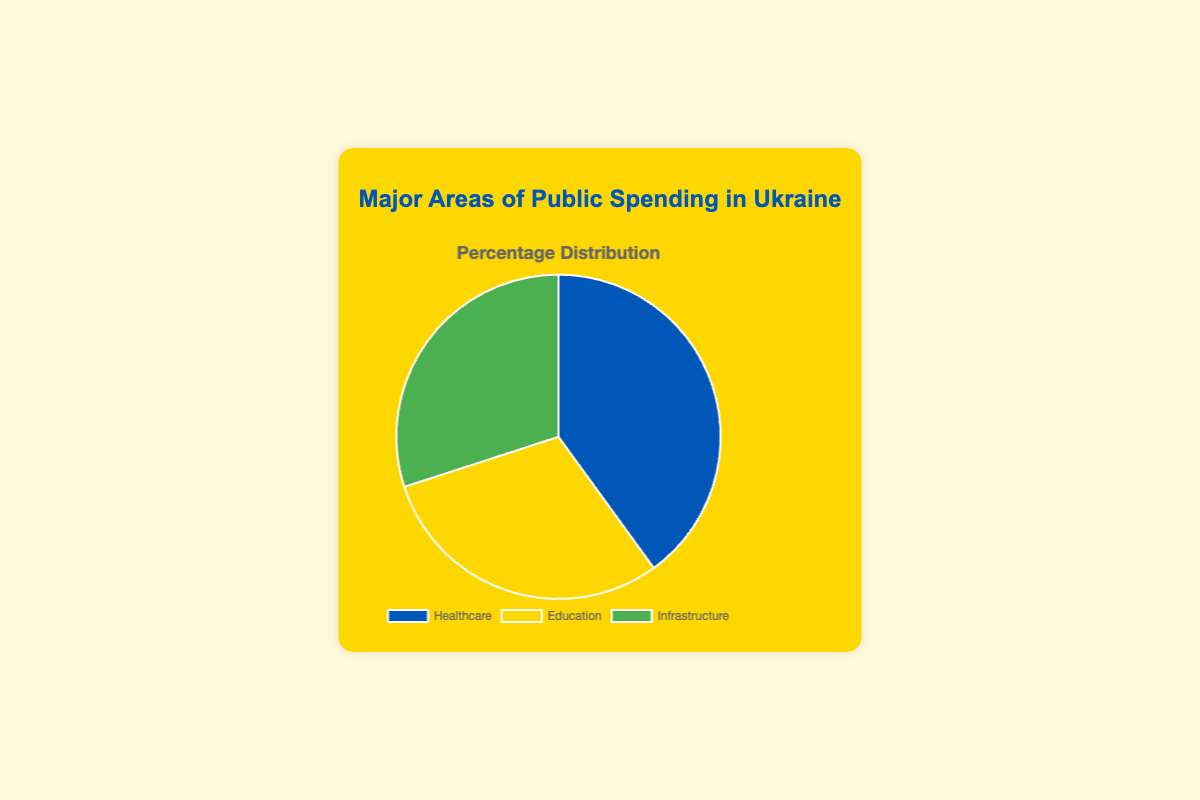Which category has the highest percentage? The pie chart shows the data distribution among Healthcare, Education, and Infrastructure. Healthcare is shown as having the largest slice of 40%.
Answer: Healthcare What is the total percentage of spending on Education and Infrastructure? The pie chart displays Education at 30% and Infrastructure at 30%. Adding these two percentages together gives 30% + 30% = 60%.
Answer: 60% Among Healthcare, Education, and Infrastructure, which two categories have equal spending? By examining the pie chart, it is evident that both Education and Infrastructure each make up 30% of the total spending.
Answer: Education and Infrastructure What is the percentage difference between Healthcare and Education? The pie chart shows Healthcare at 40% and Education at 30%. The difference is 40% - 30% = 10%.
Answer: 10% Which category is represented by the green section of the pie chart? The chart uses different colors for each category. The green section corresponds to Infrastructure as indicated in the legend.
Answer: Infrastructure Calculate the average percentage spent on all three categories. The data points provided are 40% for Healthcare, 30% for Education, and 30% for Infrastructure. The average is calculated as (40% + 30% + 30%) / 3 = 100% / 3 = 33.33%.
Answer: 33.33% What is the ratio of spending on Healthcare to Education? The chart indicates Healthcare at 40% and Education at 30%. The ratio is 40:30, which simplifies to 4:3.
Answer: 4:3 Which category has a 10% lesser share than Healthcare? The pie chart shows that Education has a 10% lesser share than Healthcare (40% Healthcare, 30% Education).
Answer: Education What is the sum of the two smallest categories' percentages? According to the pie chart, both Education and Infrastructure have the smallest shares of 30% each. The sum is 30% + 30% = 60%.
Answer: 60% Identify the category represented by the blue section of the pie chart. The colors in the chart help differentiate categories. The blue section represents Healthcare as shown in the legend.
Answer: Healthcare 